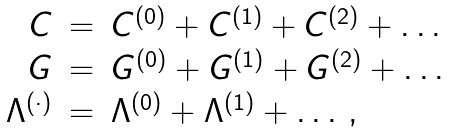<formula> <loc_0><loc_0><loc_500><loc_500>\begin{array} { r c l } { C } & { = } & { { C ^ { ( 0 ) } + C ^ { ( 1 ) } + C ^ { ( 2 ) } + \dots } } \\ { G } & { = } & { { G ^ { ( 0 ) } + G ^ { ( 1 ) } + G ^ { ( 2 ) } + \dots } } \\ { { \Lambda ^ { ( \cdot ) } } } & { = } & { { \Lambda ^ { ( 0 ) } + \Lambda ^ { ( 1 ) } + \dots \, , } } \end{array}</formula> 